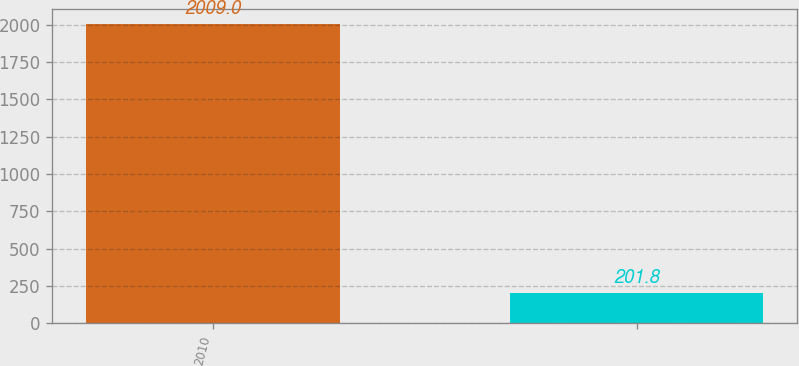<chart> <loc_0><loc_0><loc_500><loc_500><bar_chart><fcel>2010<fcel>Unnamed: 1<nl><fcel>2009<fcel>201.8<nl></chart> 